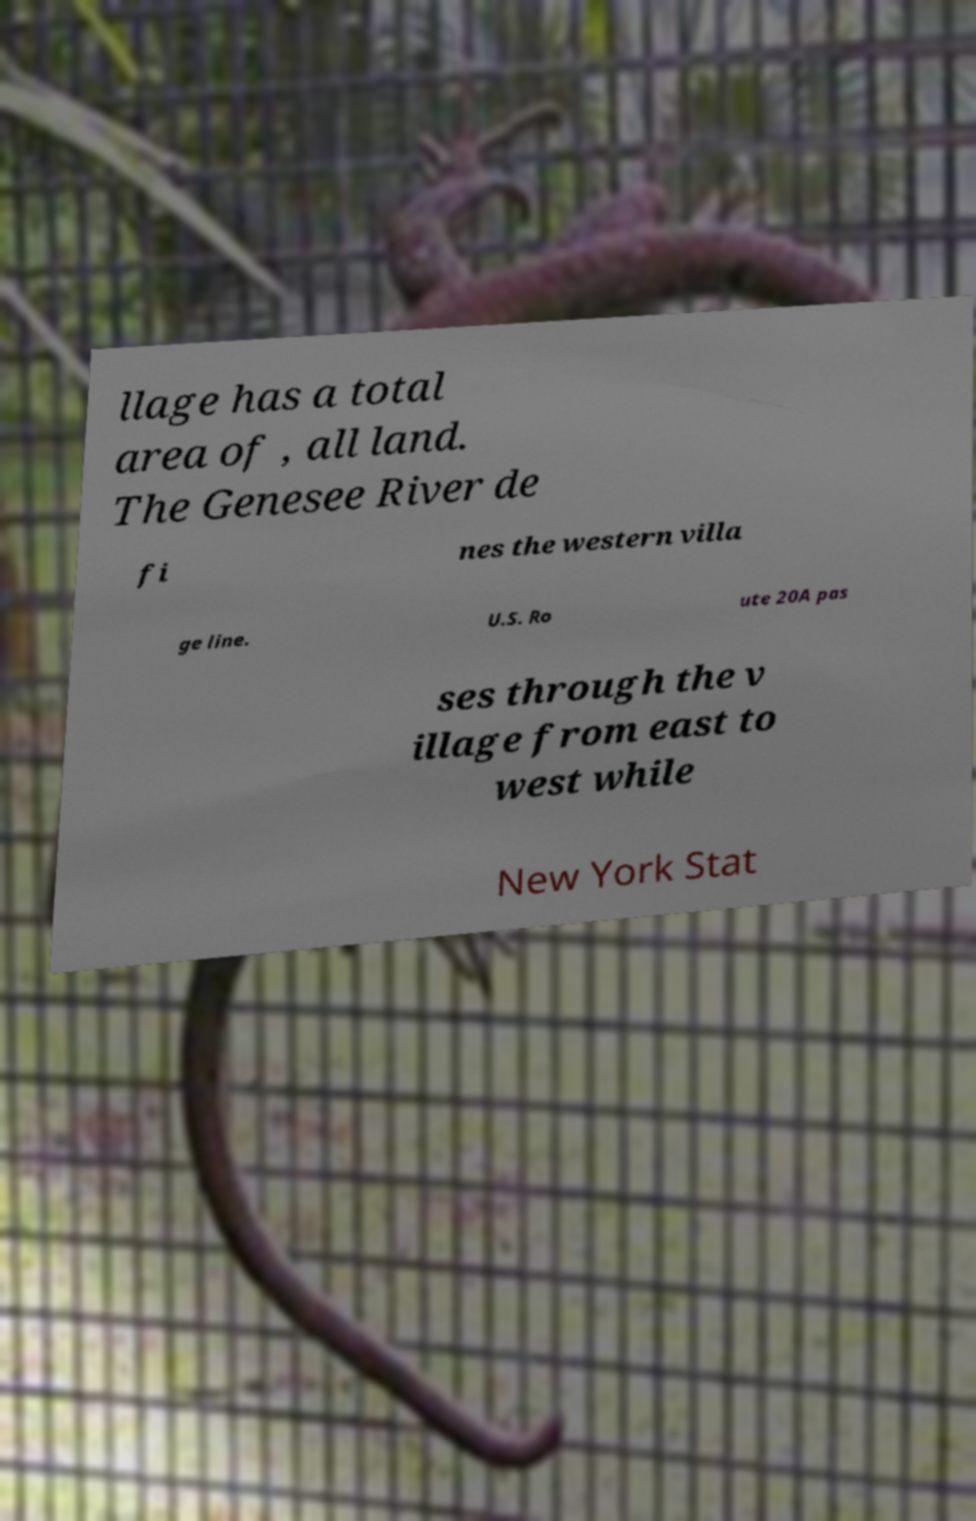Could you extract and type out the text from this image? llage has a total area of , all land. The Genesee River de fi nes the western villa ge line. U.S. Ro ute 20A pas ses through the v illage from east to west while New York Stat 